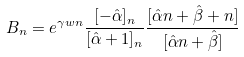Convert formula to latex. <formula><loc_0><loc_0><loc_500><loc_500>B _ { n } = e ^ { \gamma w n } \frac { [ - \hat { \alpha } ] _ { n } } { [ \hat { \alpha } + 1 ] _ { n } } \frac { [ \hat { \alpha } n + \hat { \beta } + n ] } { [ \hat { \alpha } n + \hat { \beta } ] }</formula> 